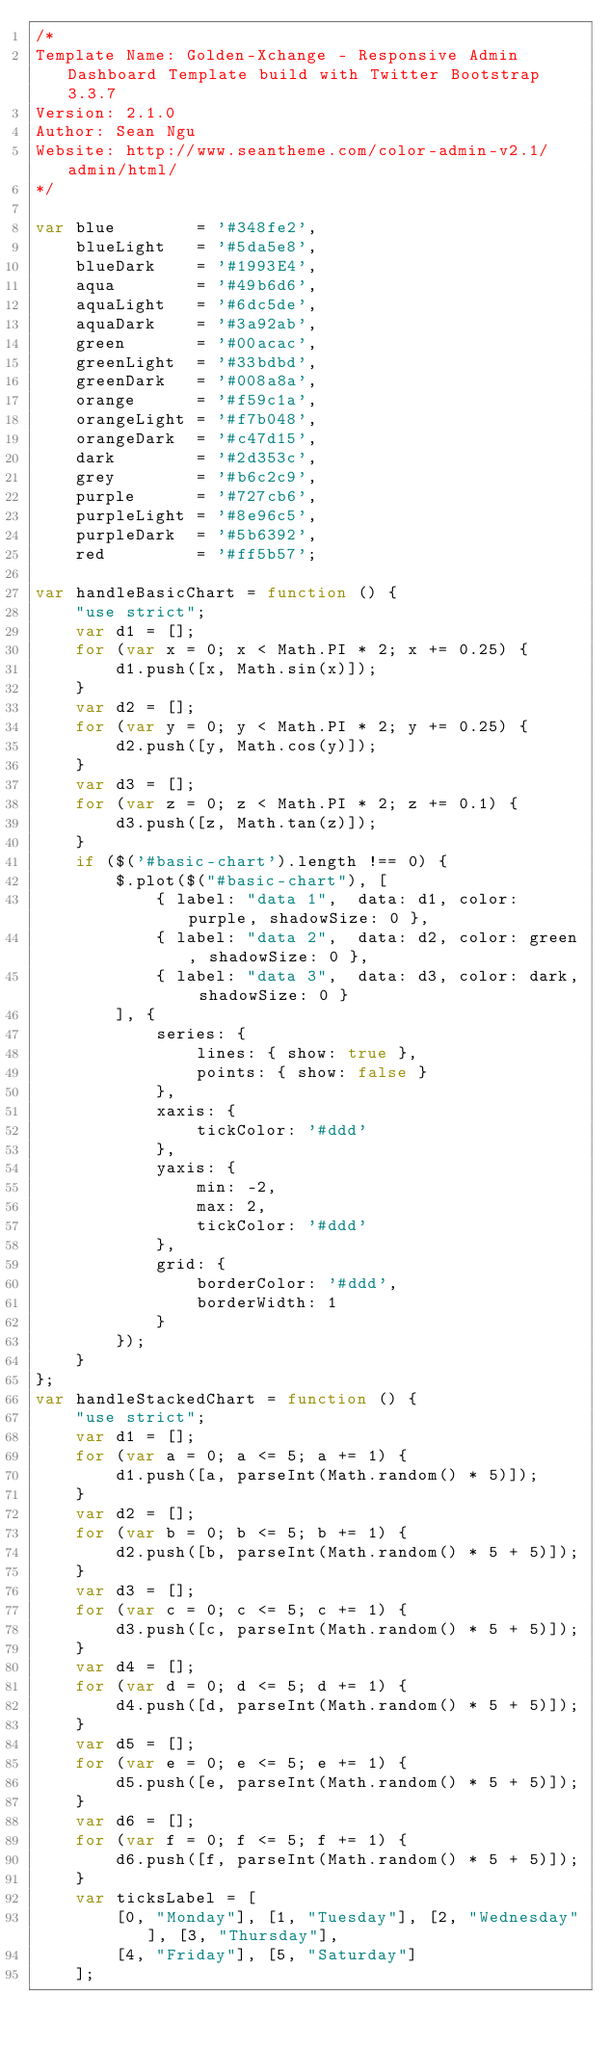Convert code to text. <code><loc_0><loc_0><loc_500><loc_500><_JavaScript_>/*
Template Name: Golden-Xchange - Responsive Admin Dashboard Template build with Twitter Bootstrap 3.3.7
Version: 2.1.0
Author: Sean Ngu
Website: http://www.seantheme.com/color-admin-v2.1/admin/html/
*/

var blue		= '#348fe2',
    blueLight	= '#5da5e8',
    blueDark	= '#1993E4',
    aqua		= '#49b6d6',
    aquaLight	= '#6dc5de',
    aquaDark	= '#3a92ab',
	green		= '#00acac',
	greenLight	= '#33bdbd',
	greenDark	= '#008a8a',
	orange		= '#f59c1a',
	orangeLight	= '#f7b048',
	orangeDark	= '#c47d15',
    dark		= '#2d353c',
    grey		= '#b6c2c9',
    purple		= '#727cb6',
    purpleLight	= '#8e96c5',
    purpleDark	= '#5b6392',
    red         = '#ff5b57';
    
var handleBasicChart = function () {
	"use strict";
	var d1 = [];
	for (var x = 0; x < Math.PI * 2; x += 0.25) {
		d1.push([x, Math.sin(x)]);
	}
	var d2 = [];
	for (var y = 0; y < Math.PI * 2; y += 0.25) {
		d2.push([y, Math.cos(y)]);
	}
	var d3 = [];
	for (var z = 0; z < Math.PI * 2; z += 0.1) {
		d3.push([z, Math.tan(z)]);
	}
	if ($('#basic-chart').length !== 0) {
        $.plot($("#basic-chart"), [
            { label: "data 1",  data: d1, color: purple, shadowSize: 0 },
            { label: "data 2",  data: d2, color: green, shadowSize: 0 },
            { label: "data 3",  data: d3, color: dark, shadowSize: 0 }
        ], {
            series: {
                lines: { show: true },
                points: { show: false }
            },
            xaxis: {
                tickColor: '#ddd'
            },
            yaxis: {
                min: -2,
                max: 2,
                tickColor: '#ddd'
            },
            grid: {
                borderColor: '#ddd',
                borderWidth: 1
            }
        });
	}
};
var handleStackedChart = function () {
	"use strict";
	var d1 = [];
    for (var a = 0; a <= 5; a += 1) {
        d1.push([a, parseInt(Math.random() * 5)]);
    }
    var d2 = [];
    for (var b = 0; b <= 5; b += 1) {
        d2.push([b, parseInt(Math.random() * 5 + 5)]);
    }
    var d3 = [];
    for (var c = 0; c <= 5; c += 1) {
        d3.push([c, parseInt(Math.random() * 5 + 5)]);
    }
    var d4 = [];
    for (var d = 0; d <= 5; d += 1) {
        d4.push([d, parseInt(Math.random() * 5 + 5)]);
    }
    var d5 = [];
    for (var e = 0; e <= 5; e += 1) {
        d5.push([e, parseInt(Math.random() * 5 + 5)]);
    }
    var d6 = [];
    for (var f = 0; f <= 5; f += 1) {
        d6.push([f, parseInt(Math.random() * 5 + 5)]);
    }
    var ticksLabel = [
        [0, "Monday"], [1, "Tuesday"], [2, "Wednesday"], [3, "Thursday"],
        [4, "Friday"], [5, "Saturday"]
    ];</code> 